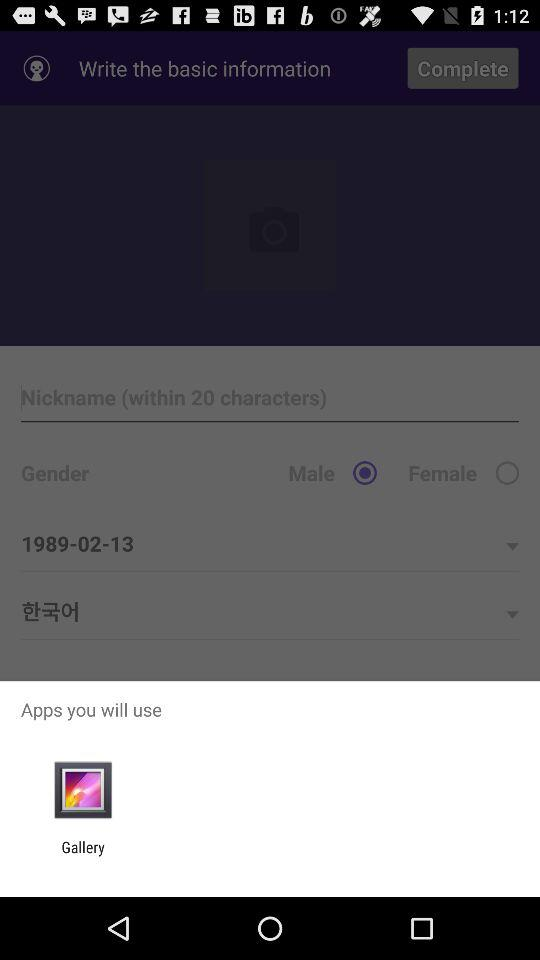How many characters can be used to write a nickname? A nickname can be written within 20 characters. 